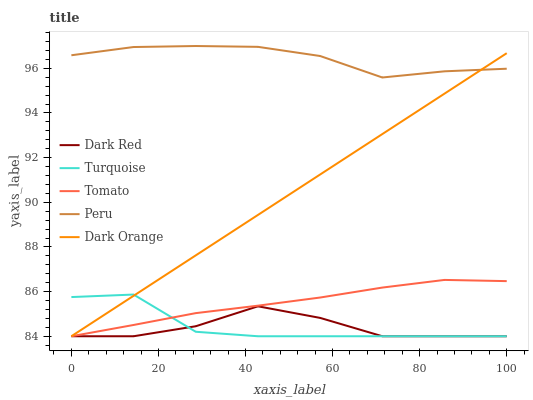Does Dark Red have the minimum area under the curve?
Answer yes or no. Yes. Does Peru have the maximum area under the curve?
Answer yes or no. Yes. Does Turquoise have the minimum area under the curve?
Answer yes or no. No. Does Turquoise have the maximum area under the curve?
Answer yes or no. No. Is Dark Orange the smoothest?
Answer yes or no. Yes. Is Turquoise the roughest?
Answer yes or no. Yes. Is Dark Red the smoothest?
Answer yes or no. No. Is Dark Red the roughest?
Answer yes or no. No. Does Tomato have the lowest value?
Answer yes or no. Yes. Does Peru have the lowest value?
Answer yes or no. No. Does Peru have the highest value?
Answer yes or no. Yes. Does Turquoise have the highest value?
Answer yes or no. No. Is Dark Red less than Peru?
Answer yes or no. Yes. Is Peru greater than Turquoise?
Answer yes or no. Yes. Does Turquoise intersect Dark Red?
Answer yes or no. Yes. Is Turquoise less than Dark Red?
Answer yes or no. No. Is Turquoise greater than Dark Red?
Answer yes or no. No. Does Dark Red intersect Peru?
Answer yes or no. No. 